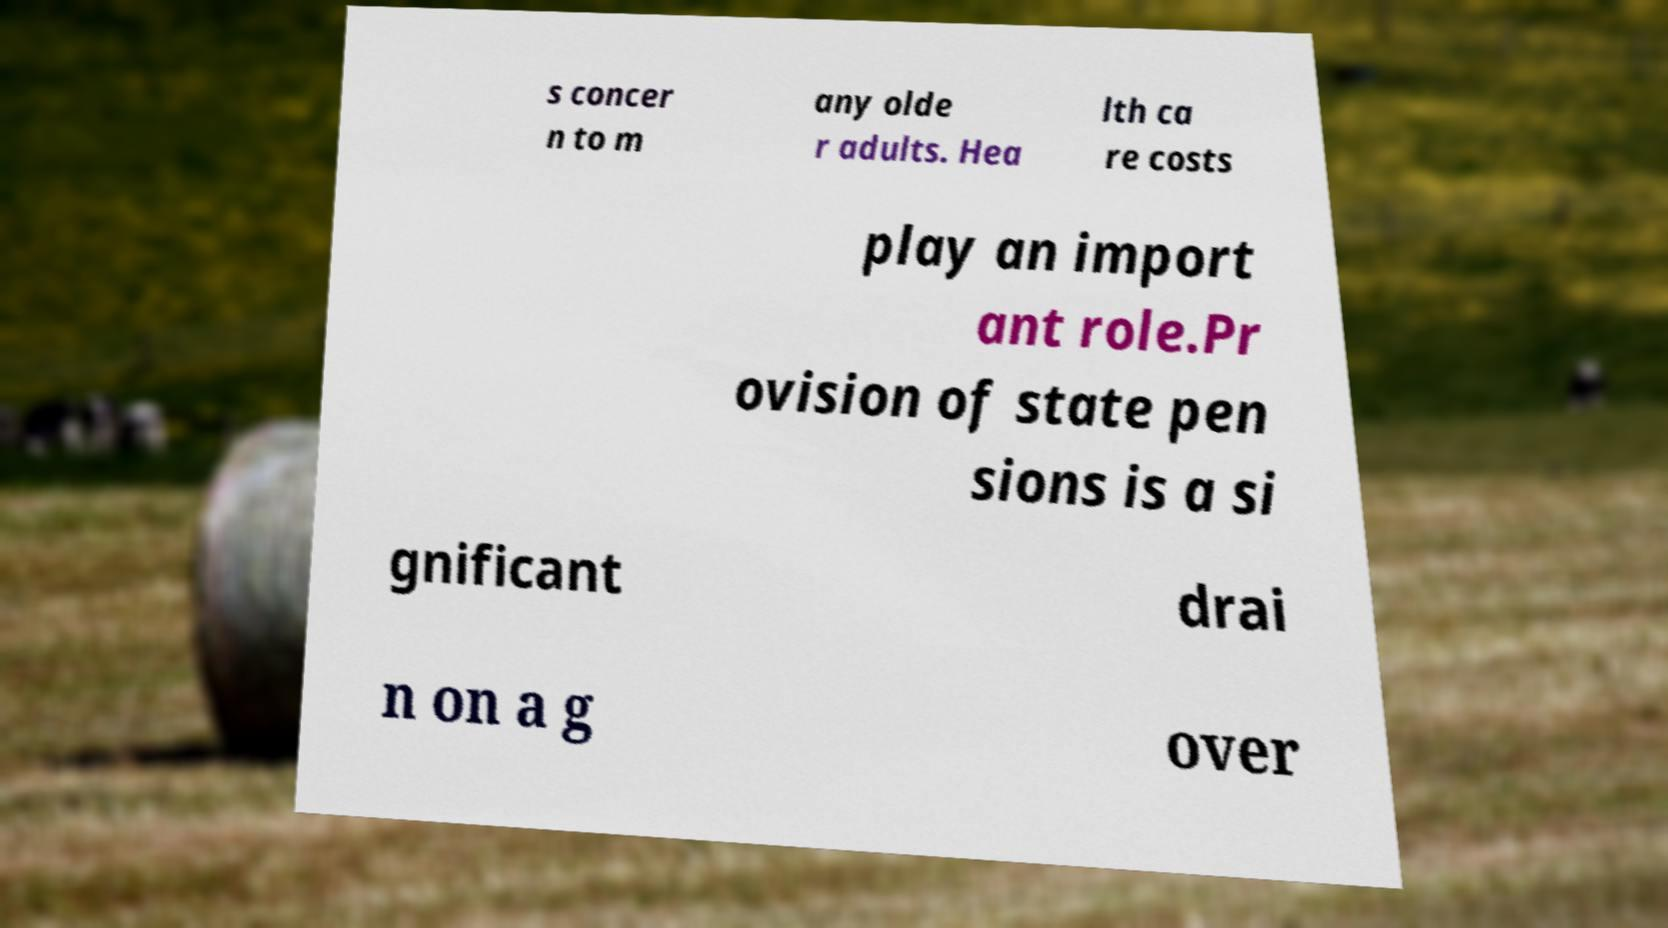Please identify and transcribe the text found in this image. s concer n to m any olde r adults. Hea lth ca re costs play an import ant role.Pr ovision of state pen sions is a si gnificant drai n on a g over 